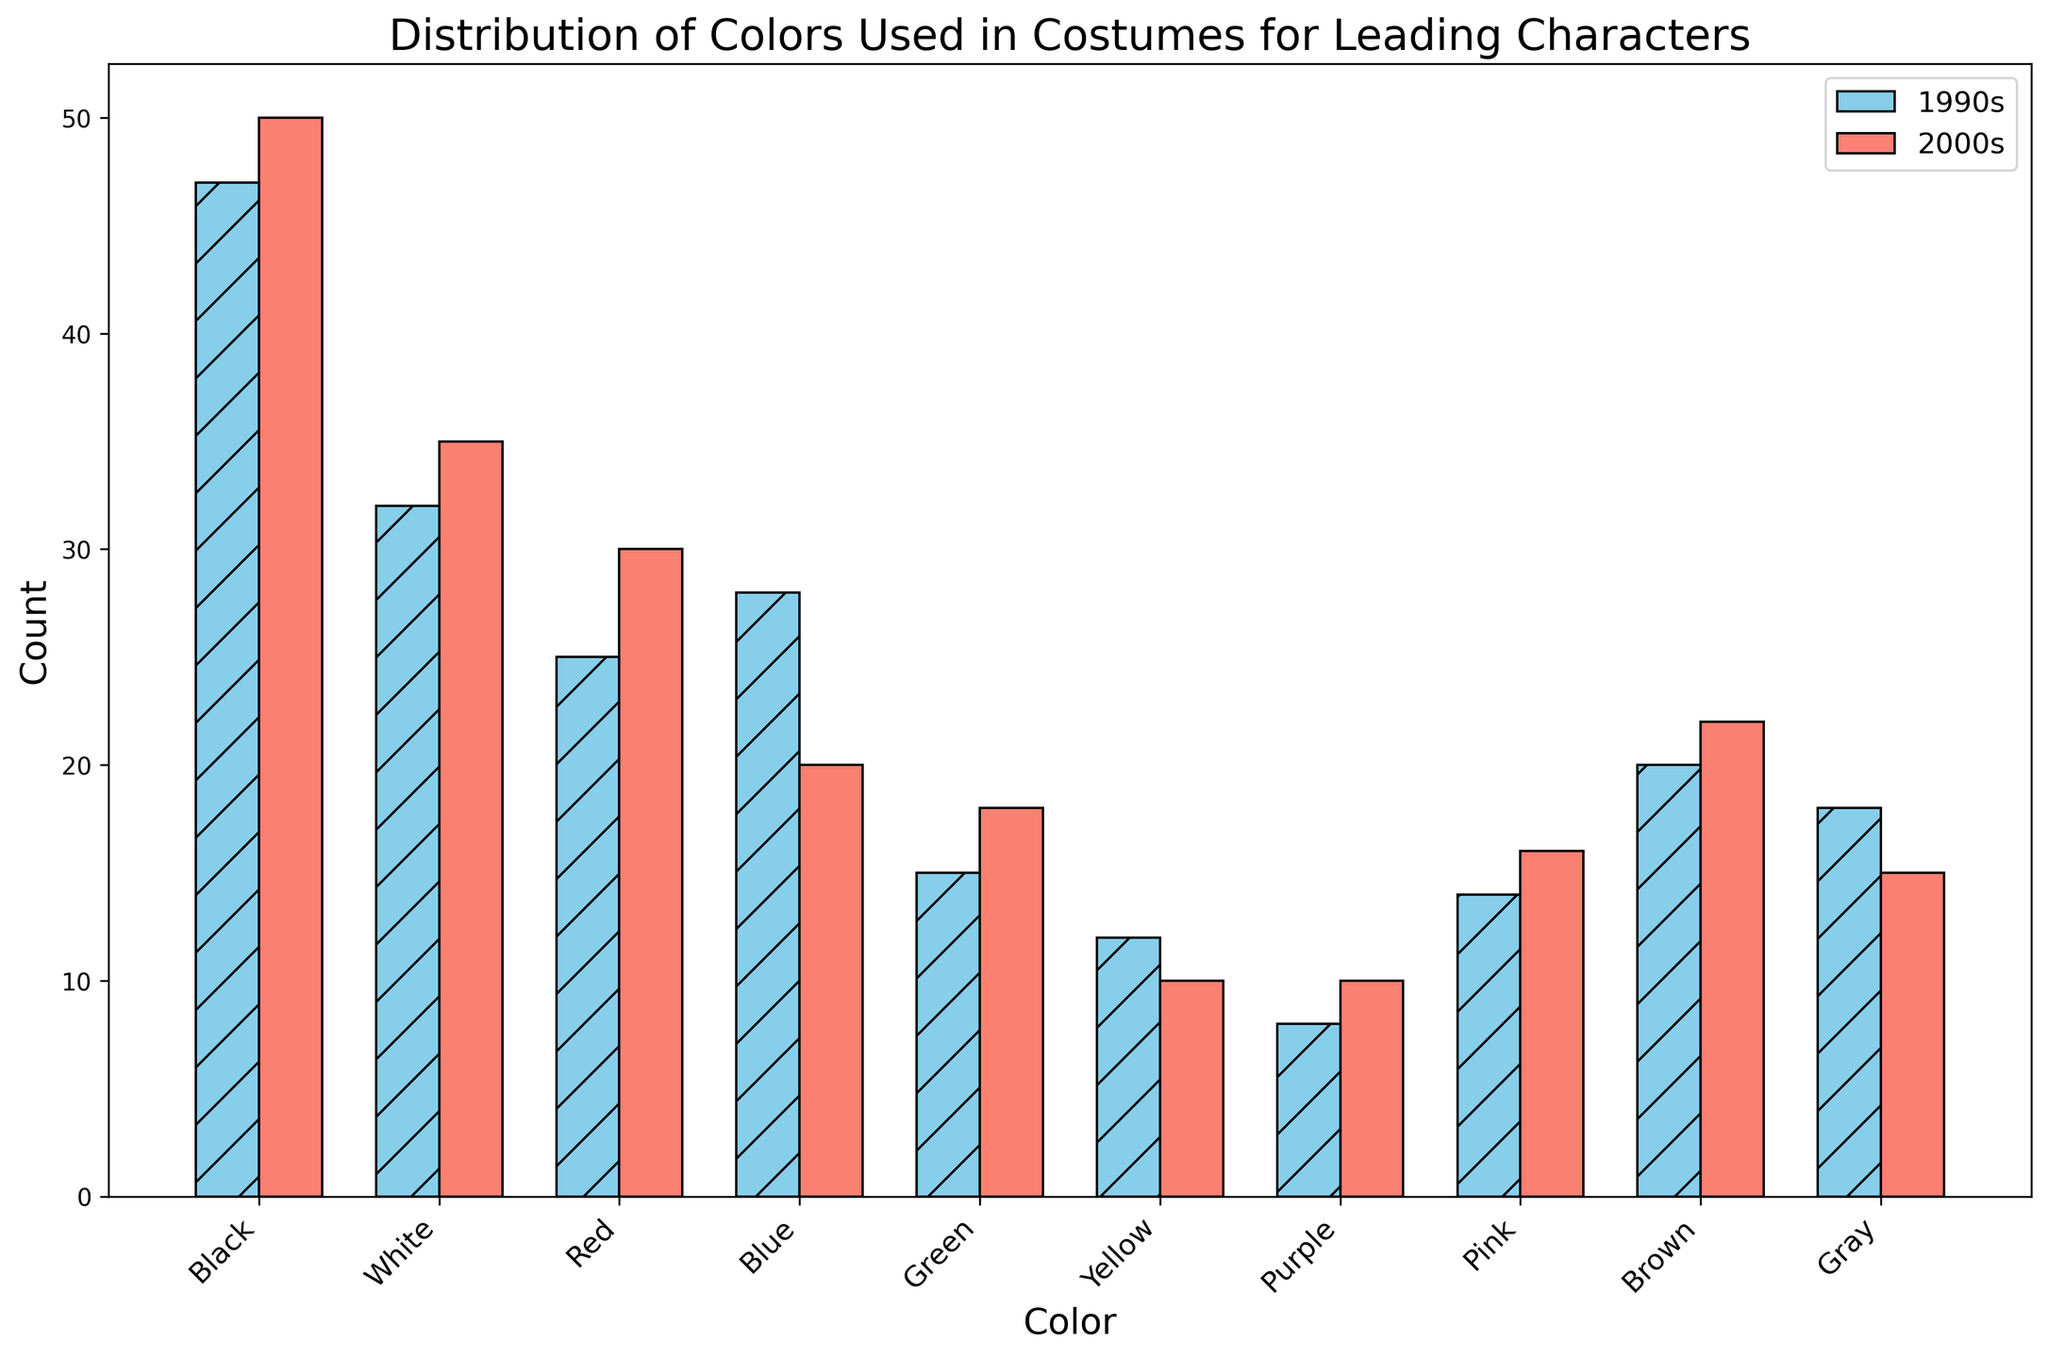What is the most frequently used color for costumes in the 2000s? By looking at the height of the bars representing the 2000s (salmon color), the highest bar corresponds to "Black" with a count of 50
Answer: Black Which color saw the largest increase in usage from the 1990s to the 2000s? To find the largest increase, compare the heights of bars for each color between the 1990s (skyblue) and the 2000s (salmon). The greatest increase occurs in "Black" (from 47 to 50)
Answer: Black How many more costumes used black in the 2000s compared to the 1990s? Subtract the count of black costumes in the 1990s (47) from the count in the 2000s (50): 50 - 47 = 3
Answer: 3 Which color was used less frequently in the 2000s compared to the 1990s? By comparing the heights of each color's bars for both decades, the colors with shorter bars in the 2000s than in the 1990s are Blue, Yellow, and Gray
Answer: Blue, Yellow, Gray What is the total count of costumes using Purple in both decades? Add the counts for purple in the 1990s (8) and the 2000s (10): 8 + 10 = 18
Answer: 18 By how much did the usage of White increase from the 1990s to the 2000s? Subtract the count of white costumes in the 1990s (32) from the count in the 2000s (35): 35 - 32 = 3
Answer: 3 Which two colors have the same count in the 2000s? Look at the counts in the 2000s; Purple and Gray both have a count of 10
Answer: Purple, Gray What is the total count of all colors in the 1990s and 2000s combined? Add up all color counts for both decades: (1990s) 47+32+25+28+15+12+8+14+20+18 + (2000s) 50+35+30+20+18+10+10+16+22+15 = 455
Answer: 455 Which decade used more Yellow costumes and by how much? Compare counts of Yellow: 1990s (12) vs. 2000s (10). Difference: 12 - 10 = 2
Answer: 1990s by 2 How does the usage pattern of Green change between the two decades? Compare the heights of the Green bars: 1990s (15) to 2000s (18), showing a slight increase of 3 from 1990s to 2000s
Answer: Slight increase 